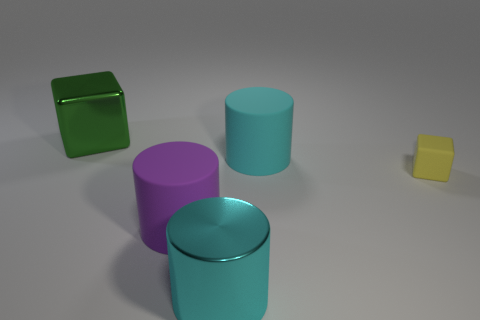Add 3 cyan objects. How many objects exist? 8 Subtract all cylinders. How many objects are left? 2 Add 4 large shiny things. How many large shiny things exist? 6 Subtract 0 gray balls. How many objects are left? 5 Subtract all big brown metal cylinders. Subtract all green metal blocks. How many objects are left? 4 Add 4 cylinders. How many cylinders are left? 7 